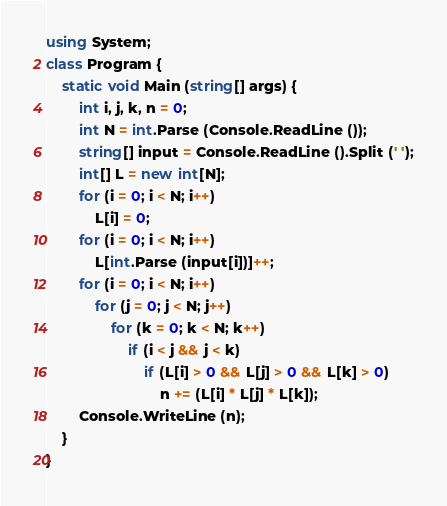Convert code to text. <code><loc_0><loc_0><loc_500><loc_500><_C#_>using System;
class Program {
    static void Main (string[] args) {
        int i, j, k, n = 0;
        int N = int.Parse (Console.ReadLine ());
        string[] input = Console.ReadLine ().Split (' ');
        int[] L = new int[N];
        for (i = 0; i < N; i++)
            L[i] = 0;
        for (i = 0; i < N; i++)
            L[int.Parse (input[i])]++;
        for (i = 0; i < N; i++)
            for (j = 0; j < N; j++)
                for (k = 0; k < N; k++)
                    if (i < j && j < k)
                        if (L[i] > 0 && L[j] > 0 && L[k] > 0)
                            n += (L[i] * L[j] * L[k]);
        Console.WriteLine (n);
    }
}</code> 